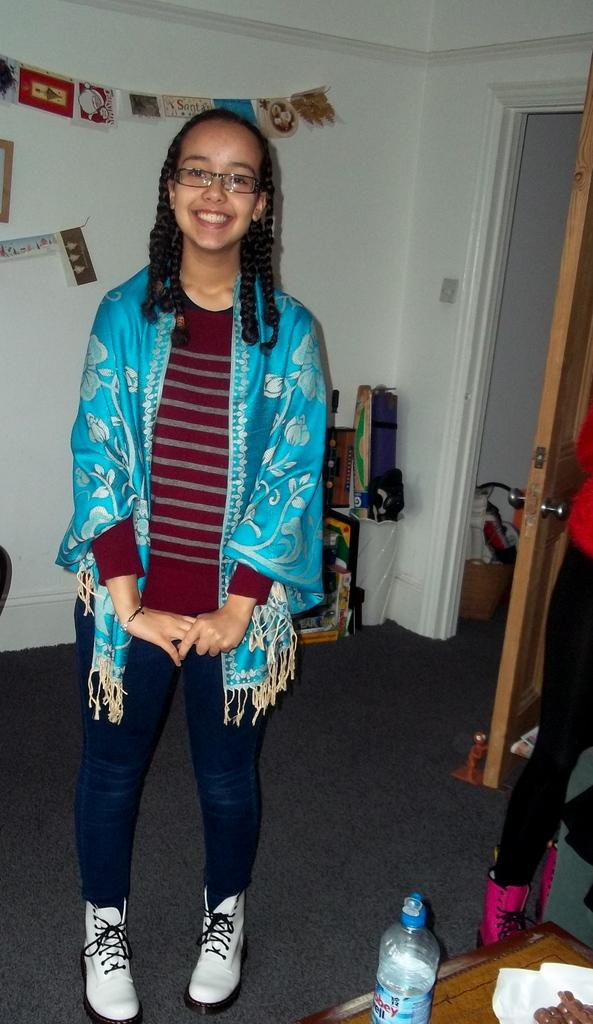What is the main subject of the image? There is a person in the image. What is the person doing in the image? The person is standing on the floor and smiling. What can be seen on the person's face? The person is wearing spectacles. What is visible in the background of the image? There is a wall and a door in the background of the image. What other object is present in the image? There is a bottle in the image. How many horses are visible in the image? There are no horses present in the image. What type of edge can be seen on the person's clothing in the image? There is no mention of the person's clothing having any specific edges in the provided facts. 